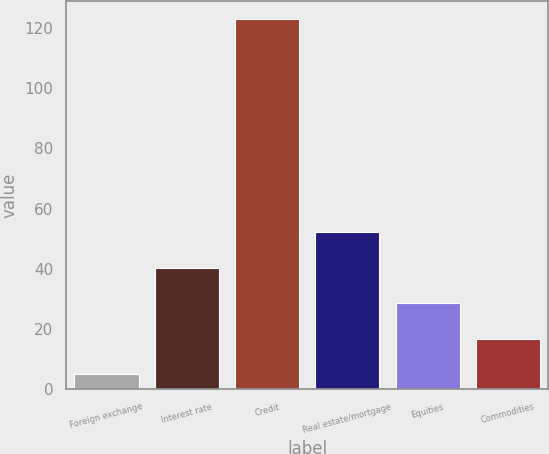Convert chart to OTSL. <chart><loc_0><loc_0><loc_500><loc_500><bar_chart><fcel>Foreign exchange<fcel>Interest rate<fcel>Credit<fcel>Real estate/mortgage<fcel>Equities<fcel>Commodities<nl><fcel>4.9<fcel>40.3<fcel>122.9<fcel>52.1<fcel>28.5<fcel>16.7<nl></chart> 